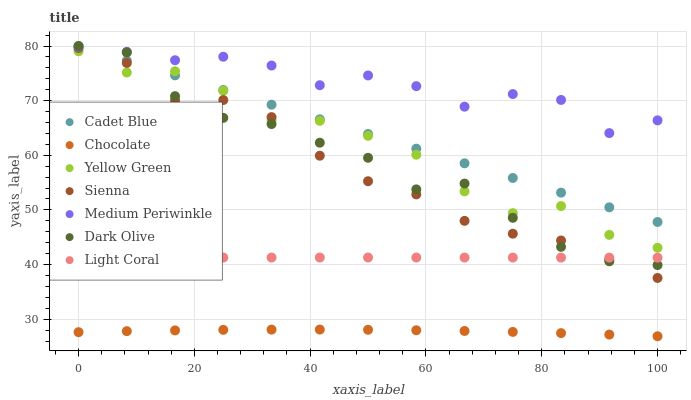Does Chocolate have the minimum area under the curve?
Answer yes or no. Yes. Does Medium Periwinkle have the maximum area under the curve?
Answer yes or no. Yes. Does Cadet Blue have the minimum area under the curve?
Answer yes or no. No. Does Cadet Blue have the maximum area under the curve?
Answer yes or no. No. Is Cadet Blue the smoothest?
Answer yes or no. Yes. Is Medium Periwinkle the roughest?
Answer yes or no. Yes. Is Yellow Green the smoothest?
Answer yes or no. No. Is Yellow Green the roughest?
Answer yes or no. No. Does Chocolate have the lowest value?
Answer yes or no. Yes. Does Cadet Blue have the lowest value?
Answer yes or no. No. Does Dark Olive have the highest value?
Answer yes or no. Yes. Does Yellow Green have the highest value?
Answer yes or no. No. Is Sienna less than Cadet Blue?
Answer yes or no. Yes. Is Yellow Green greater than Chocolate?
Answer yes or no. Yes. Does Light Coral intersect Dark Olive?
Answer yes or no. Yes. Is Light Coral less than Dark Olive?
Answer yes or no. No. Is Light Coral greater than Dark Olive?
Answer yes or no. No. Does Sienna intersect Cadet Blue?
Answer yes or no. No. 